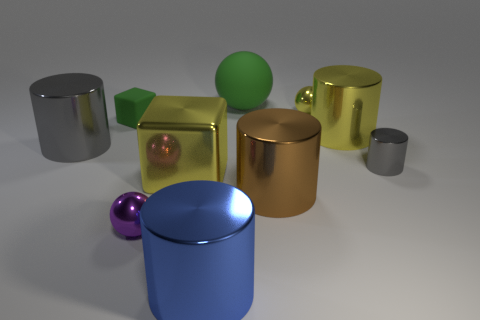Subtract all gray cylinders. How many were subtracted if there are1gray cylinders left? 1 Add 8 large gray metallic things. How many large gray metallic things exist? 9 Subtract all yellow cubes. How many cubes are left? 1 Subtract all yellow cylinders. How many cylinders are left? 4 Subtract 1 green spheres. How many objects are left? 9 Subtract all blocks. How many objects are left? 8 Subtract 3 cylinders. How many cylinders are left? 2 Subtract all green cylinders. Subtract all red blocks. How many cylinders are left? 5 Subtract all green cubes. How many green spheres are left? 1 Subtract all green matte cylinders. Subtract all tiny things. How many objects are left? 6 